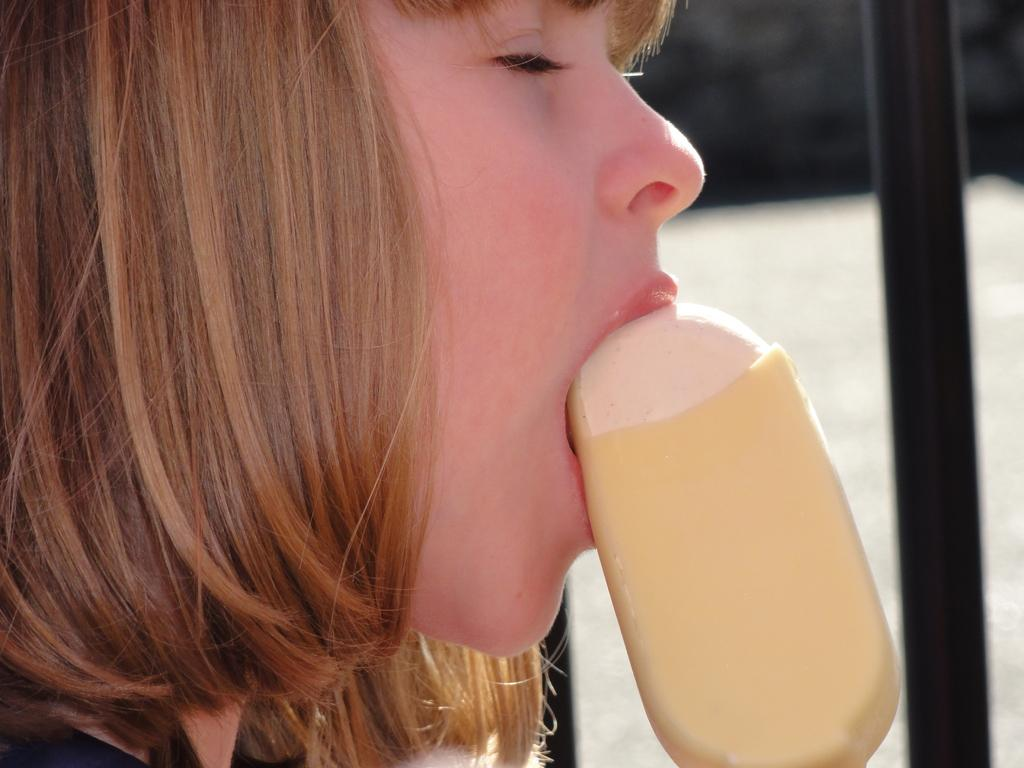Who is the main subject in the image? There is a girl in the image. What is the girl holding in the image? The girl is holding an ice-cream. What can be seen on the right side of the image? There is a black pole on the right side of the image. What is the value of the self in the image? There is no reference to a "self" or any value associated with it in the image. 